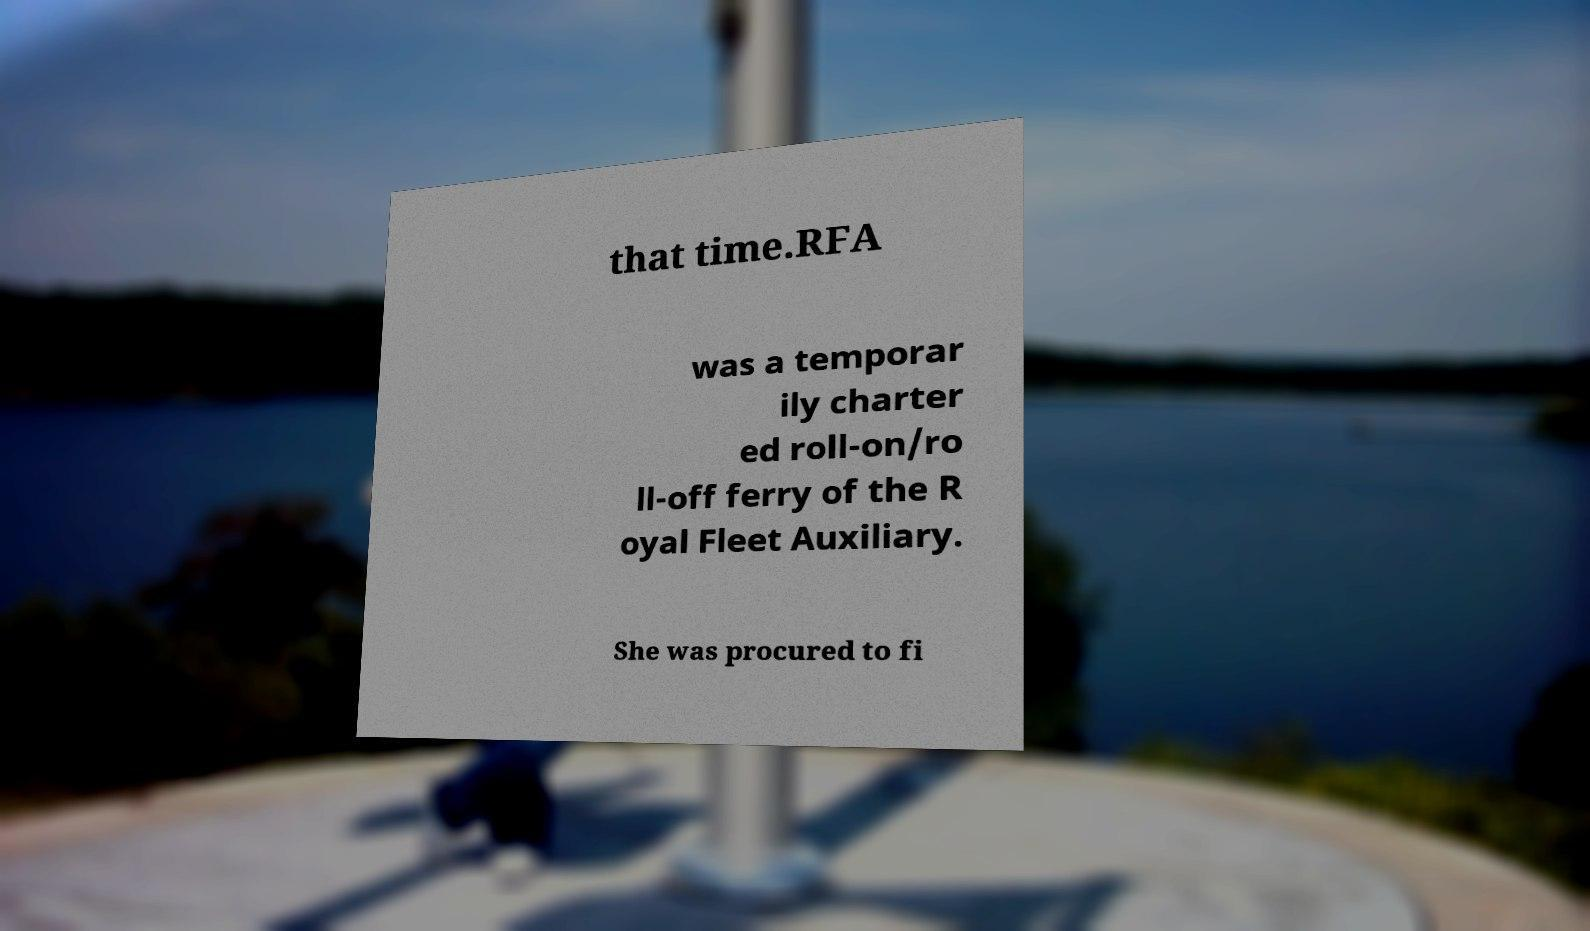What messages or text are displayed in this image? I need them in a readable, typed format. that time.RFA was a temporar ily charter ed roll-on/ro ll-off ferry of the R oyal Fleet Auxiliary. She was procured to fi 